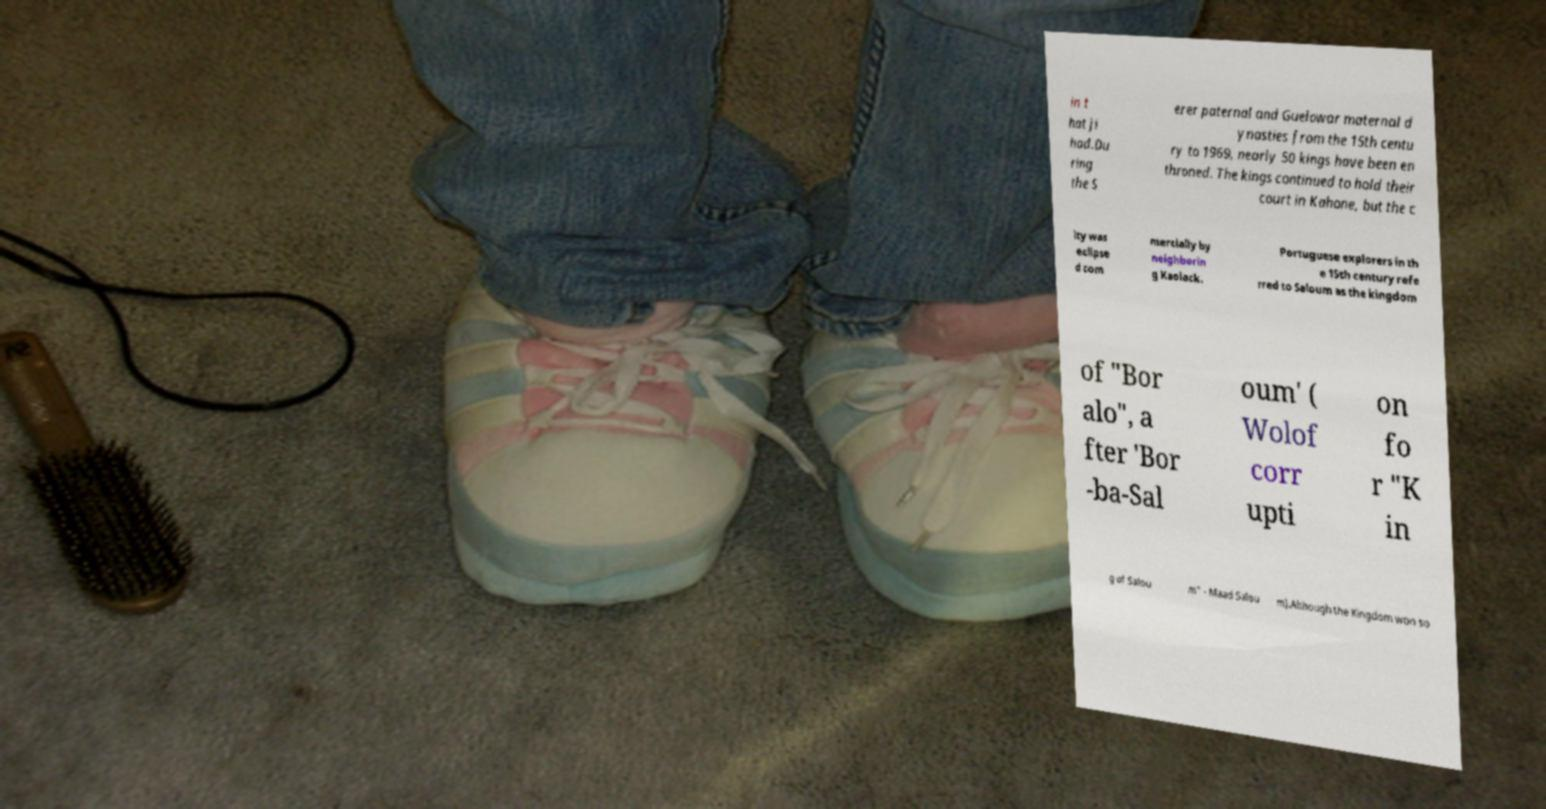Please read and relay the text visible in this image. What does it say? in t hat ji had.Du ring the S erer paternal and Guelowar maternal d ynasties from the 15th centu ry to 1969, nearly 50 kings have been en throned. The kings continued to hold their court in Kahone, but the c ity was eclipse d com mercially by neighborin g Kaolack. Portuguese explorers in th e 15th century refe rred to Saloum as the kingdom of "Bor alo", a fter 'Bor -ba-Sal oum' ( Wolof corr upti on fo r "K in g of Salou m" - Maad Salou m).Although the Kingdom won so 